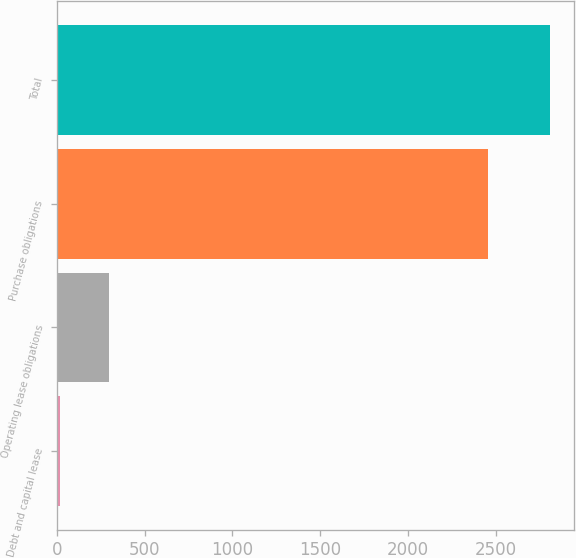Convert chart to OTSL. <chart><loc_0><loc_0><loc_500><loc_500><bar_chart><fcel>Debt and capital lease<fcel>Operating lease obligations<fcel>Purchase obligations<fcel>Total<nl><fcel>16<fcel>295.2<fcel>2458<fcel>2808<nl></chart> 